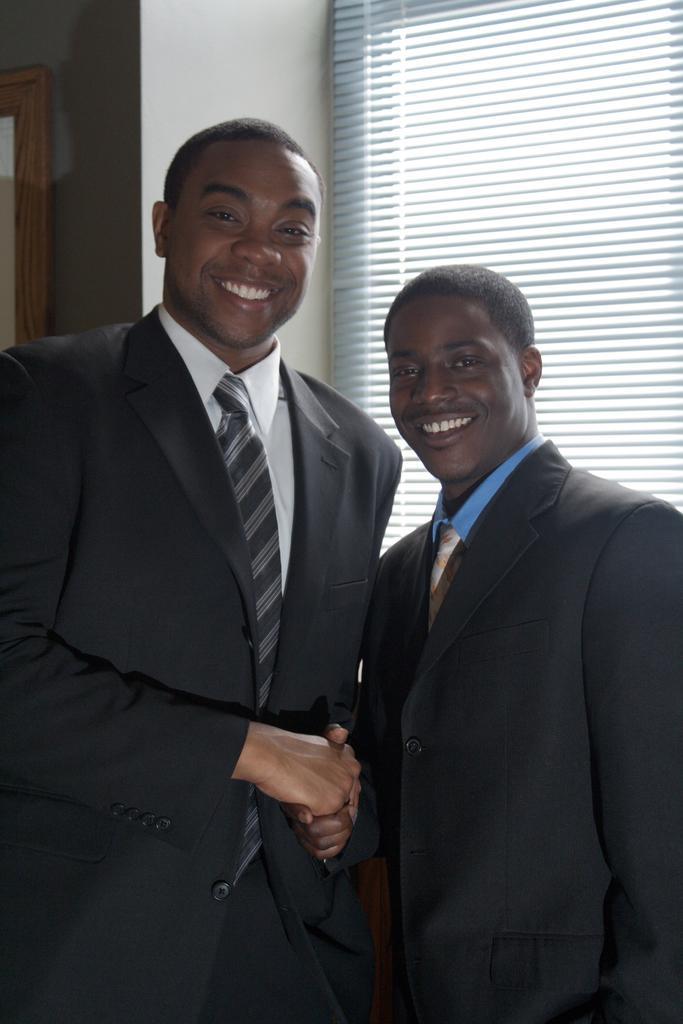Describe this image in one or two sentences. In this image there are two people standing with a smile on their face and they are shaking hands, behind them there is a wall and a window. 